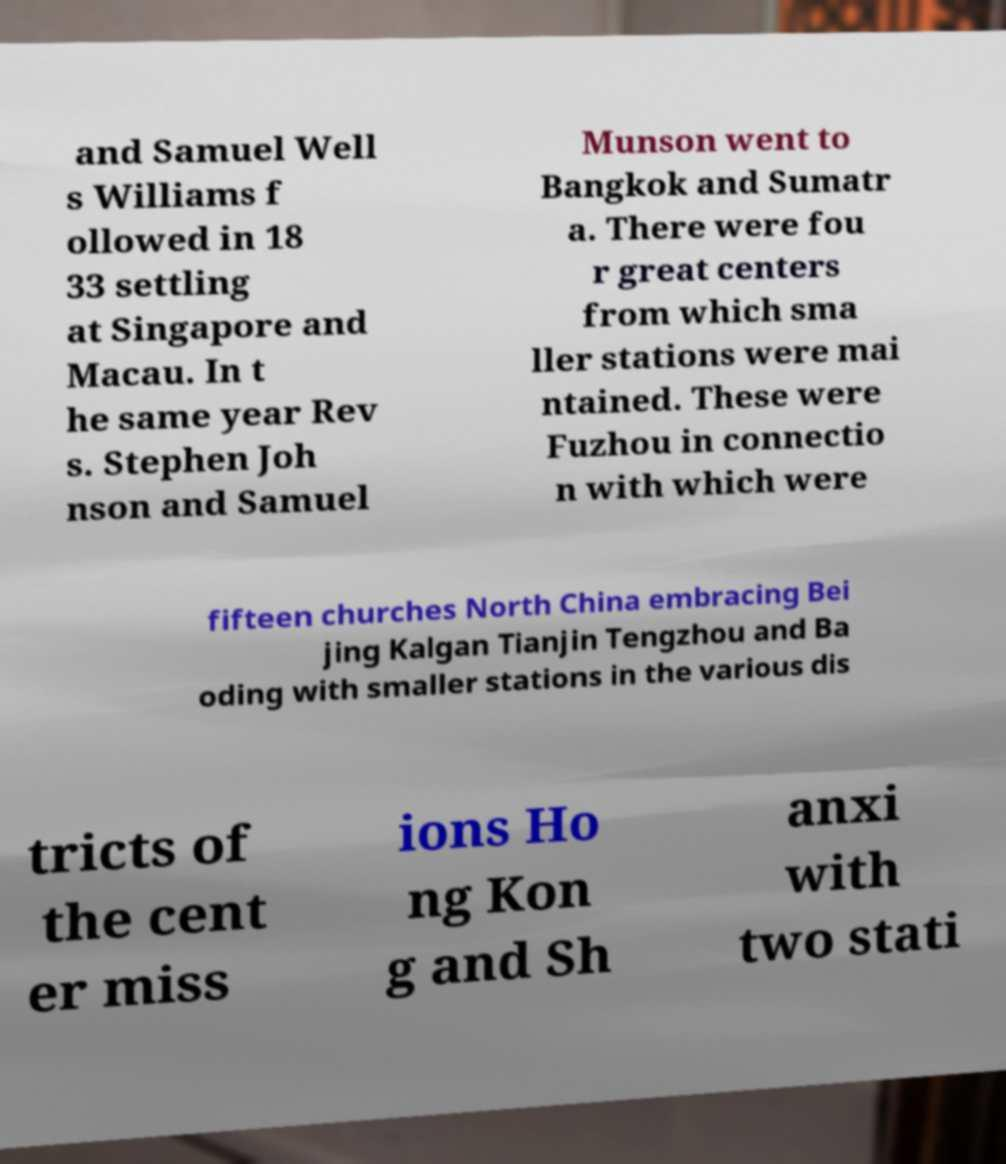Could you extract and type out the text from this image? and Samuel Well s Williams f ollowed in 18 33 settling at Singapore and Macau. In t he same year Rev s. Stephen Joh nson and Samuel Munson went to Bangkok and Sumatr a. There were fou r great centers from which sma ller stations were mai ntained. These were Fuzhou in connectio n with which were fifteen churches North China embracing Bei jing Kalgan Tianjin Tengzhou and Ba oding with smaller stations in the various dis tricts of the cent er miss ions Ho ng Kon g and Sh anxi with two stati 